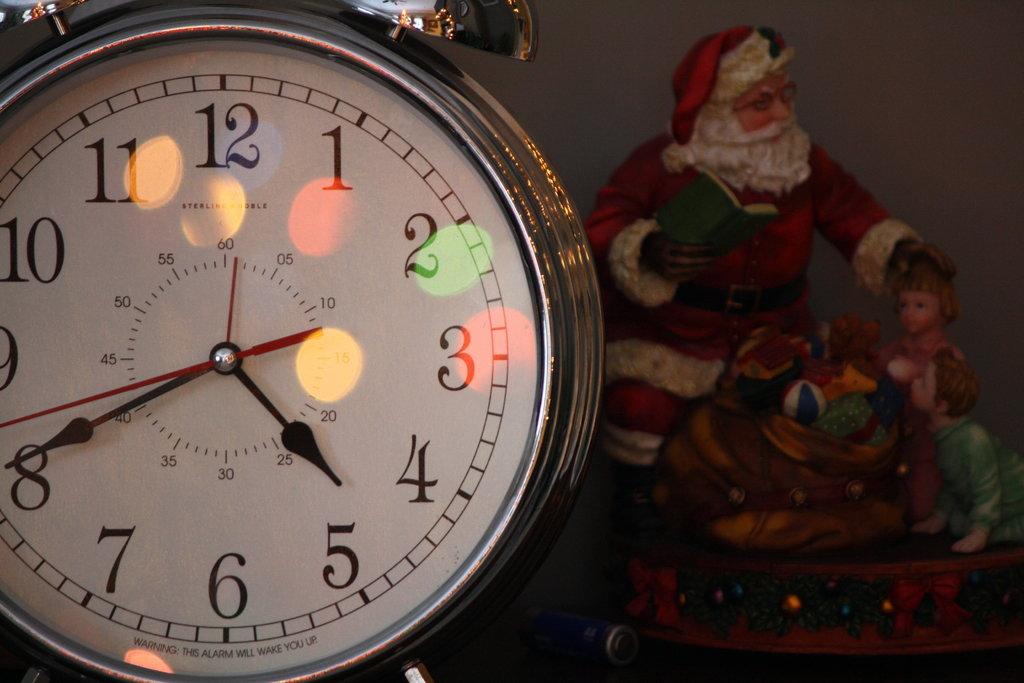What time is shown on the clock?
Your answer should be very brief. 4:40. 